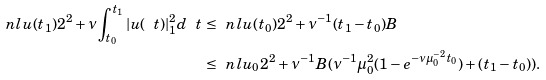Convert formula to latex. <formula><loc_0><loc_0><loc_500><loc_500>\ n l { u ( t _ { 1 } ) } { 2 } ^ { 2 } + \nu \int _ { t _ { 0 } } ^ { t _ { 1 } } | u ( \ t ) | _ { 1 } ^ { 2 } d \ t & \, \leq \, \ n l { u ( t _ { 0 } ) } { 2 } ^ { 2 } + \nu ^ { - 1 } ( t _ { 1 } - t _ { 0 } ) B \\ & \, \leq \, \ n l { u _ { 0 } } { 2 } ^ { 2 } + \nu ^ { - 1 } B ( \nu ^ { - 1 } \mu _ { 0 } ^ { 2 } ( 1 - e ^ { - \nu \mu ^ { - 2 } _ { 0 } t _ { 0 } } ) + ( t _ { 1 } - t _ { 0 } ) ) .</formula> 